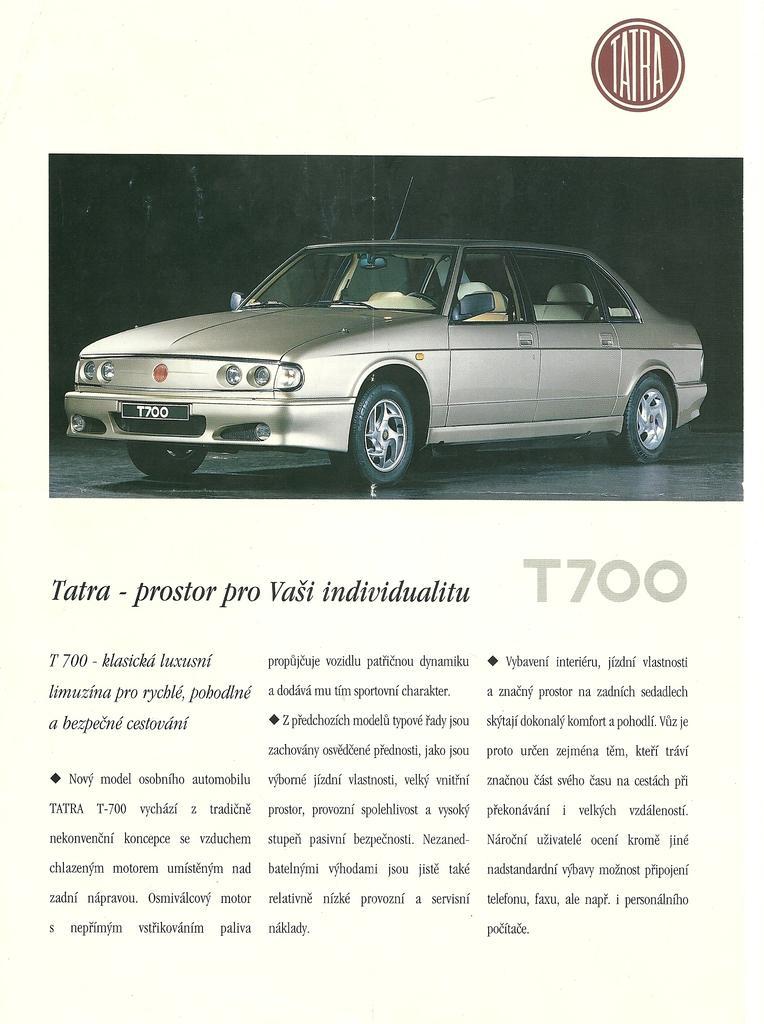Describe this image in one or two sentences. In this picture, we can see a poster with some text and some images on it. 